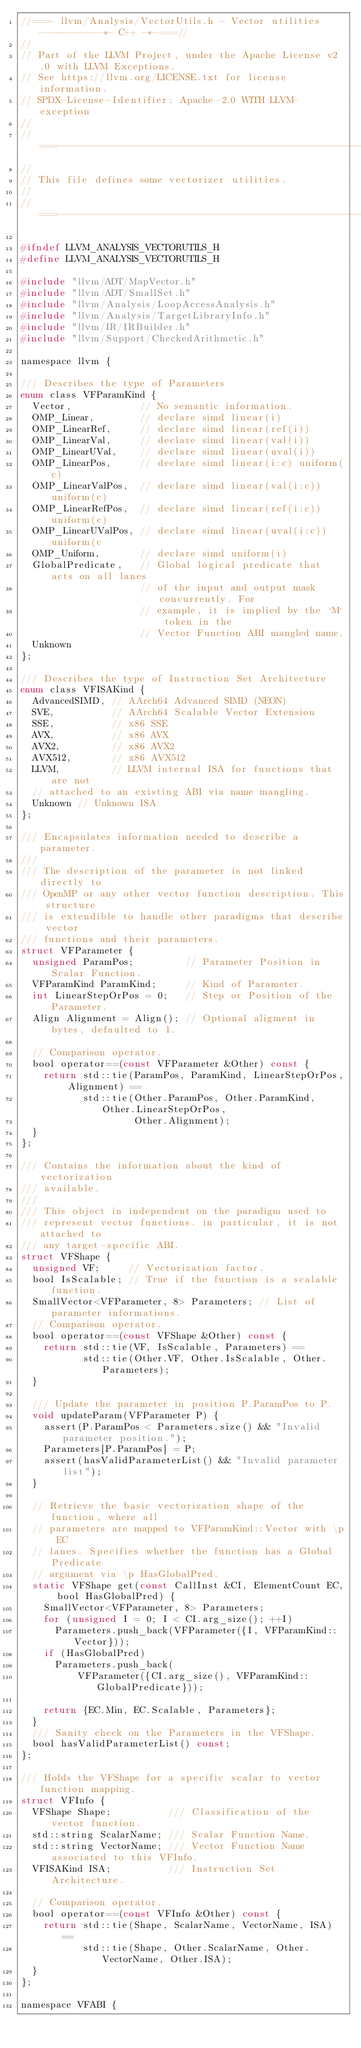<code> <loc_0><loc_0><loc_500><loc_500><_C_>//===- llvm/Analysis/VectorUtils.h - Vector utilities -----------*- C++ -*-===//
//
// Part of the LLVM Project, under the Apache License v2.0 with LLVM Exceptions.
// See https://llvm.org/LICENSE.txt for license information.
// SPDX-License-Identifier: Apache-2.0 WITH LLVM-exception
//
//===----------------------------------------------------------------------===//
//
// This file defines some vectorizer utilities.
//
//===----------------------------------------------------------------------===//

#ifndef LLVM_ANALYSIS_VECTORUTILS_H
#define LLVM_ANALYSIS_VECTORUTILS_H

#include "llvm/ADT/MapVector.h"
#include "llvm/ADT/SmallSet.h"
#include "llvm/Analysis/LoopAccessAnalysis.h"
#include "llvm/Analysis/TargetLibraryInfo.h"
#include "llvm/IR/IRBuilder.h"
#include "llvm/Support/CheckedArithmetic.h"

namespace llvm {

/// Describes the type of Parameters
enum class VFParamKind {
  Vector,            // No semantic information.
  OMP_Linear,        // declare simd linear(i)
  OMP_LinearRef,     // declare simd linear(ref(i))
  OMP_LinearVal,     // declare simd linear(val(i))
  OMP_LinearUVal,    // declare simd linear(uval(i))
  OMP_LinearPos,     // declare simd linear(i:c) uniform(c)
  OMP_LinearValPos,  // declare simd linear(val(i:c)) uniform(c)
  OMP_LinearRefPos,  // declare simd linear(ref(i:c)) uniform(c)
  OMP_LinearUValPos, // declare simd linear(uval(i:c)) uniform(c
  OMP_Uniform,       // declare simd uniform(i)
  GlobalPredicate,   // Global logical predicate that acts on all lanes
                     // of the input and output mask concurrently. For
                     // example, it is implied by the `M` token in the
                     // Vector Function ABI mangled name.
  Unknown
};

/// Describes the type of Instruction Set Architecture
enum class VFISAKind {
  AdvancedSIMD, // AArch64 Advanced SIMD (NEON)
  SVE,          // AArch64 Scalable Vector Extension
  SSE,          // x86 SSE
  AVX,          // x86 AVX
  AVX2,         // x86 AVX2
  AVX512,       // x86 AVX512
  LLVM,         // LLVM internal ISA for functions that are not
  // attached to an existing ABI via name mangling.
  Unknown // Unknown ISA
};

/// Encapsulates information needed to describe a parameter.
///
/// The description of the parameter is not linked directly to
/// OpenMP or any other vector function description. This structure
/// is extendible to handle other paradigms that describe vector
/// functions and their parameters.
struct VFParameter {
  unsigned ParamPos;         // Parameter Position in Scalar Function.
  VFParamKind ParamKind;     // Kind of Parameter.
  int LinearStepOrPos = 0;   // Step or Position of the Parameter.
  Align Alignment = Align(); // Optional aligment in bytes, defaulted to 1.

  // Comparison operator.
  bool operator==(const VFParameter &Other) const {
    return std::tie(ParamPos, ParamKind, LinearStepOrPos, Alignment) ==
           std::tie(Other.ParamPos, Other.ParamKind, Other.LinearStepOrPos,
                    Other.Alignment);
  }
};

/// Contains the information about the kind of vectorization
/// available.
///
/// This object in independent on the paradigm used to
/// represent vector functions. in particular, it is not attached to
/// any target-specific ABI.
struct VFShape {
  unsigned VF;     // Vectorization factor.
  bool IsScalable; // True if the function is a scalable function.
  SmallVector<VFParameter, 8> Parameters; // List of parameter informations.
  // Comparison operator.
  bool operator==(const VFShape &Other) const {
    return std::tie(VF, IsScalable, Parameters) ==
           std::tie(Other.VF, Other.IsScalable, Other.Parameters);
  }

  /// Update the parameter in position P.ParamPos to P.
  void updateParam(VFParameter P) {
    assert(P.ParamPos < Parameters.size() && "Invalid parameter position.");
    Parameters[P.ParamPos] = P;
    assert(hasValidParameterList() && "Invalid parameter list");
  }

  // Retrieve the basic vectorization shape of the function, where all
  // parameters are mapped to VFParamKind::Vector with \p EC
  // lanes. Specifies whether the function has a Global Predicate
  // argument via \p HasGlobalPred.
  static VFShape get(const CallInst &CI, ElementCount EC, bool HasGlobalPred) {
    SmallVector<VFParameter, 8> Parameters;
    for (unsigned I = 0; I < CI.arg_size(); ++I)
      Parameters.push_back(VFParameter({I, VFParamKind::Vector}));
    if (HasGlobalPred)
      Parameters.push_back(
          VFParameter({CI.arg_size(), VFParamKind::GlobalPredicate}));

    return {EC.Min, EC.Scalable, Parameters};
  }
  /// Sanity check on the Parameters in the VFShape.
  bool hasValidParameterList() const;
};

/// Holds the VFShape for a specific scalar to vector function mapping.
struct VFInfo {
  VFShape Shape;          /// Classification of the vector function.
  std::string ScalarName; /// Scalar Function Name.
  std::string VectorName; /// Vector Function Name associated to this VFInfo.
  VFISAKind ISA;          /// Instruction Set Architecture.

  // Comparison operator.
  bool operator==(const VFInfo &Other) const {
    return std::tie(Shape, ScalarName, VectorName, ISA) ==
           std::tie(Shape, Other.ScalarName, Other.VectorName, Other.ISA);
  }
};

namespace VFABI {</code> 